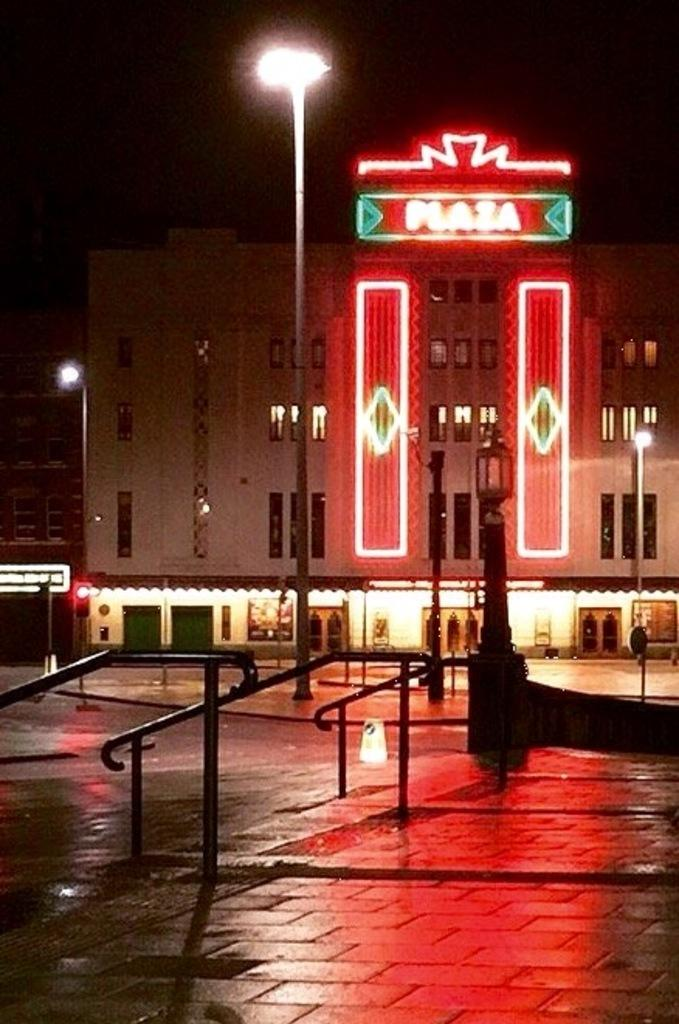What type of structures can be seen in the image? There are buildings in the image. What feature is visible on the buildings? There are windows visible in the image. Is there any writing or text on any of the buildings? Yes, there is text written on at least one building. What type of lighting is present in the image? Street lights are present in the image. What type of architectural feature can be seen in the image? There is railing visible in the image. How many sisters are standing next to the buildings in the image? There are no sisters present in the image; it only features buildings, windows, text, street lights, and railing. 